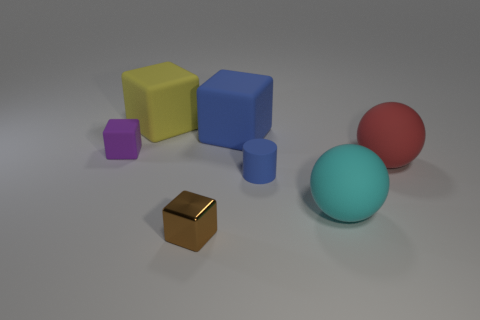Do the small rubber thing in front of the red matte object and the large matte block in front of the yellow thing have the same color?
Give a very brief answer. Yes. How many blocks have the same color as the cylinder?
Provide a short and direct response. 1. There is a large matte thing that is in front of the red thing; is it the same shape as the blue rubber thing that is in front of the red matte ball?
Give a very brief answer. No. Is the number of large objects behind the large cyan sphere greater than the number of blue rubber cylinders that are on the left side of the large yellow matte object?
Offer a terse response. Yes. What size is the rubber block that is the same color as the rubber cylinder?
Your answer should be very brief. Large. Does the blue rubber cube have the same size as the sphere behind the big cyan ball?
Offer a terse response. Yes. How many cylinders are tiny objects or big red objects?
Provide a short and direct response. 1. What is the size of the red thing that is made of the same material as the large yellow object?
Make the answer very short. Large. Do the blue object that is in front of the large red matte ball and the cube that is behind the big blue object have the same size?
Your answer should be compact. No. How many objects are yellow cubes or tiny green rubber objects?
Your response must be concise. 1. 